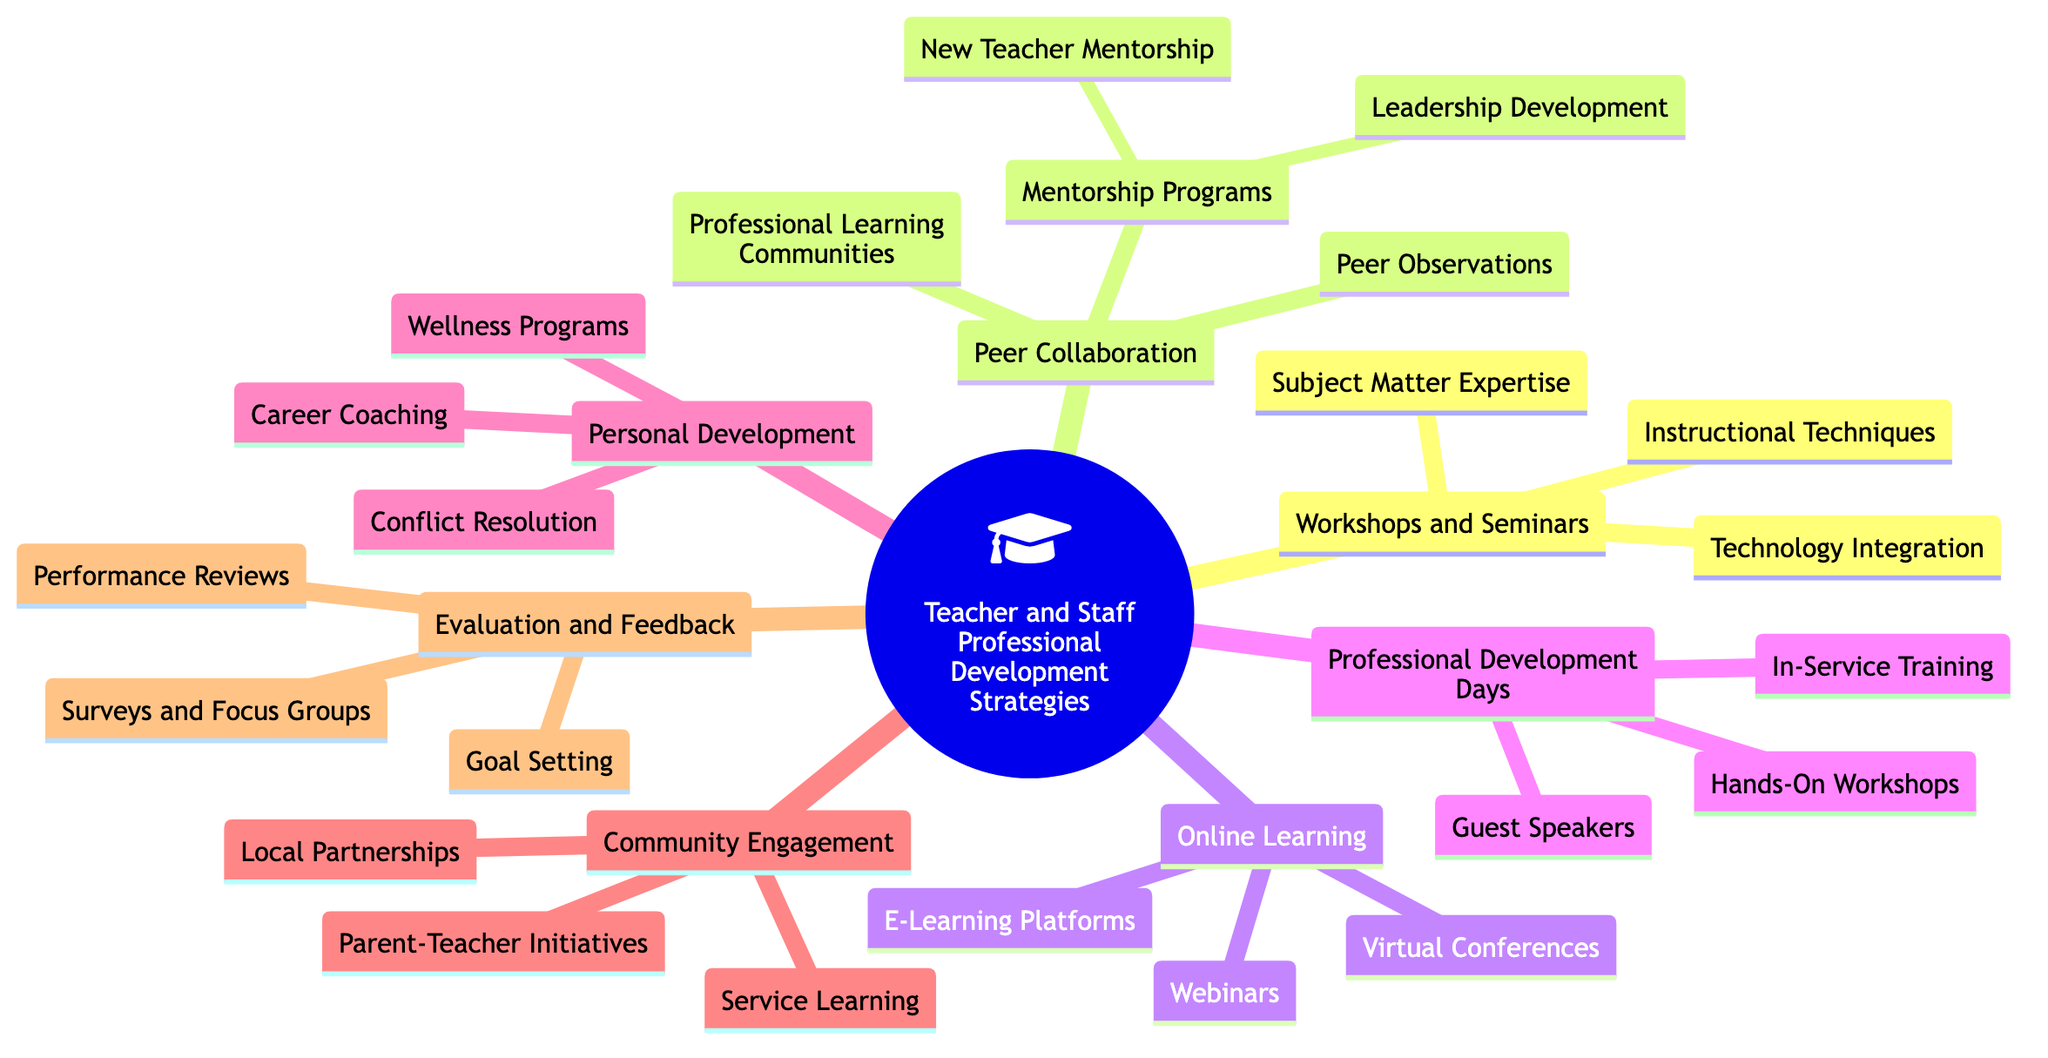what are the main categories of Professional Development Strategies? The diagram indicates that there are six main categories under Teacher and Staff Professional Development Strategies: Workshops and Seminars, Peer Collaboration, Online Learning, Professional Development Days, Personal Development, Community Engagement, and Evaluation and Feedback.
Answer: Workshops and Seminars, Peer Collaboration, Online Learning, Professional Development Days, Personal Development, Community Engagement, Evaluation and Feedback how many types of Peer Collaboration are listed? In the section labeled Peer Collaboration, there are three types: Professional Learning Communities, Peer Observations, and Mentorship Programs. Therefore, counting these sections gives a total of three types.
Answer: 3 what is one type of Professional Development Day? Under the category Professional Development Days, one specific type listed is In-Service Training, which indicates the kind of program that takes place on these days.
Answer: In-Service Training which category includes workshops on engaging parents? The workshops on engaging parents are found in the Community Engagement category, which focuses on initiatives that involve parents and the community in education.
Answer: Community Engagement what are the two subcategories of Mentorship Programs? The two subcategories of Mentorship Programs are New Teacher Mentorship and Leadership Development, indicating that mentorship can target both new and aspiring leaders in the school.
Answer: New Teacher Mentorship, Leadership Development what is the purpose of Surveys and Focus Groups in Evaluation and Feedback? Surveys and Focus Groups in the Evaluation and Feedback category serve as feedback mechanisms for continual improvement, indicating that they are aimed at assessing the effectiveness of professional development activities.
Answer: Feedback mechanisms for continual improvement how many types of Online Learning strategies are there? The Online Learning category encompasses three types: E-Learning Platforms, Webinars, and Virtual Conferences. Thus, the total number of types is three.
Answer: 3 which Professional Development Strategy uses guest speakers? Guest Speakers are featured in the Professional Development Days category, which suggests that inviting speakers is part of the strategies outlined for these events.
Answer: Professional Development Days what is included under Personal Development aimed at conflict? Under the category Personal Development, the specific area related to conflict is Conflict Resolution, which focuses on training techniques for mediating conflicts.
Answer: Conflict Resolution 